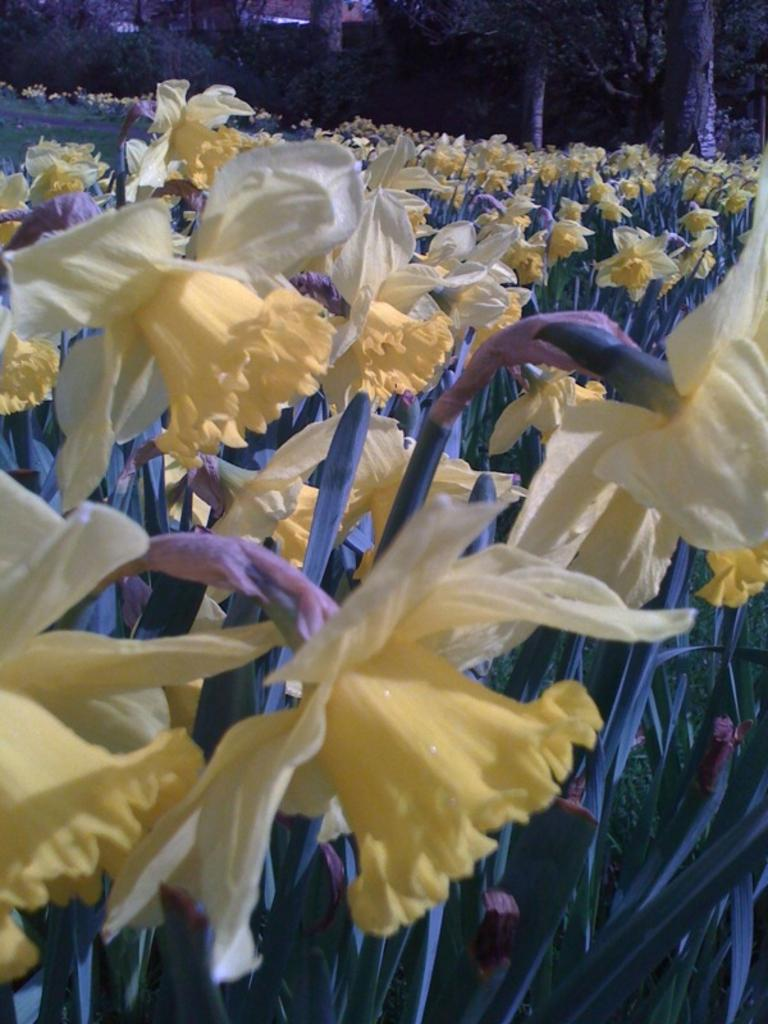What type of plants can be seen in the image? There are flowers in the image. What other natural elements are visible in the image? There are trees visible in the image. Where is the servant standing in the image? There is no servant present in the image. What type of water body can be seen in the image? There is no lake or any other water body visible in the image. 